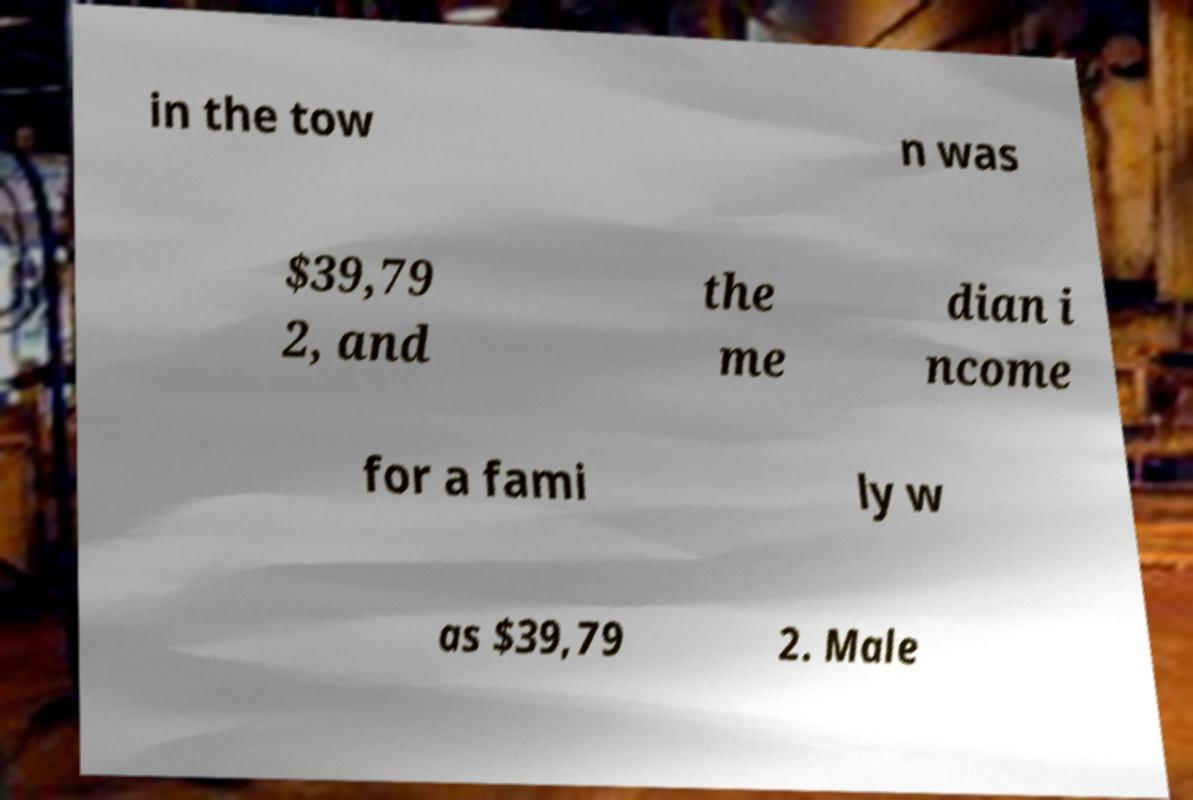There's text embedded in this image that I need extracted. Can you transcribe it verbatim? in the tow n was $39,79 2, and the me dian i ncome for a fami ly w as $39,79 2. Male 